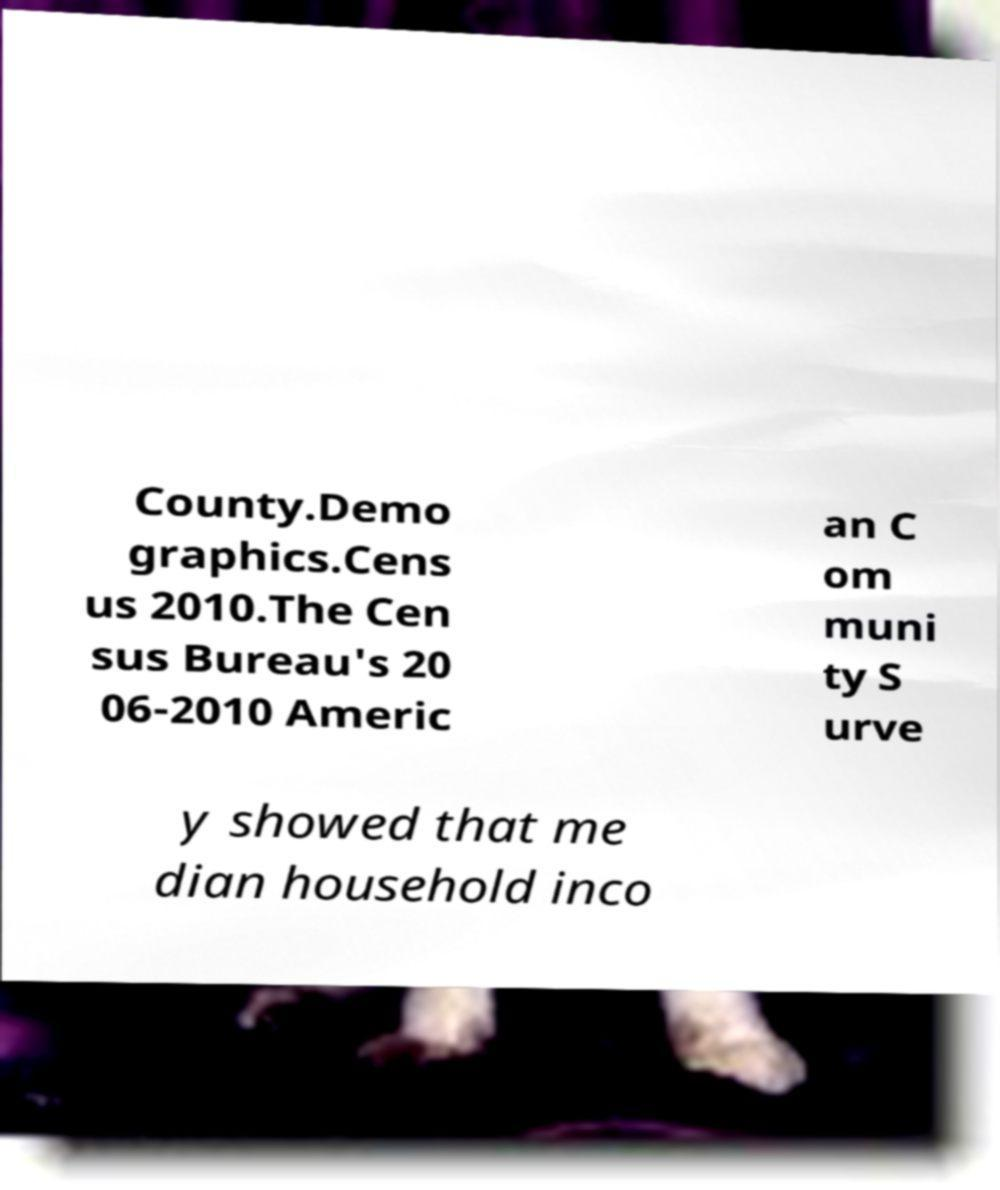I need the written content from this picture converted into text. Can you do that? County.Demo graphics.Cens us 2010.The Cen sus Bureau's 20 06-2010 Americ an C om muni ty S urve y showed that me dian household inco 